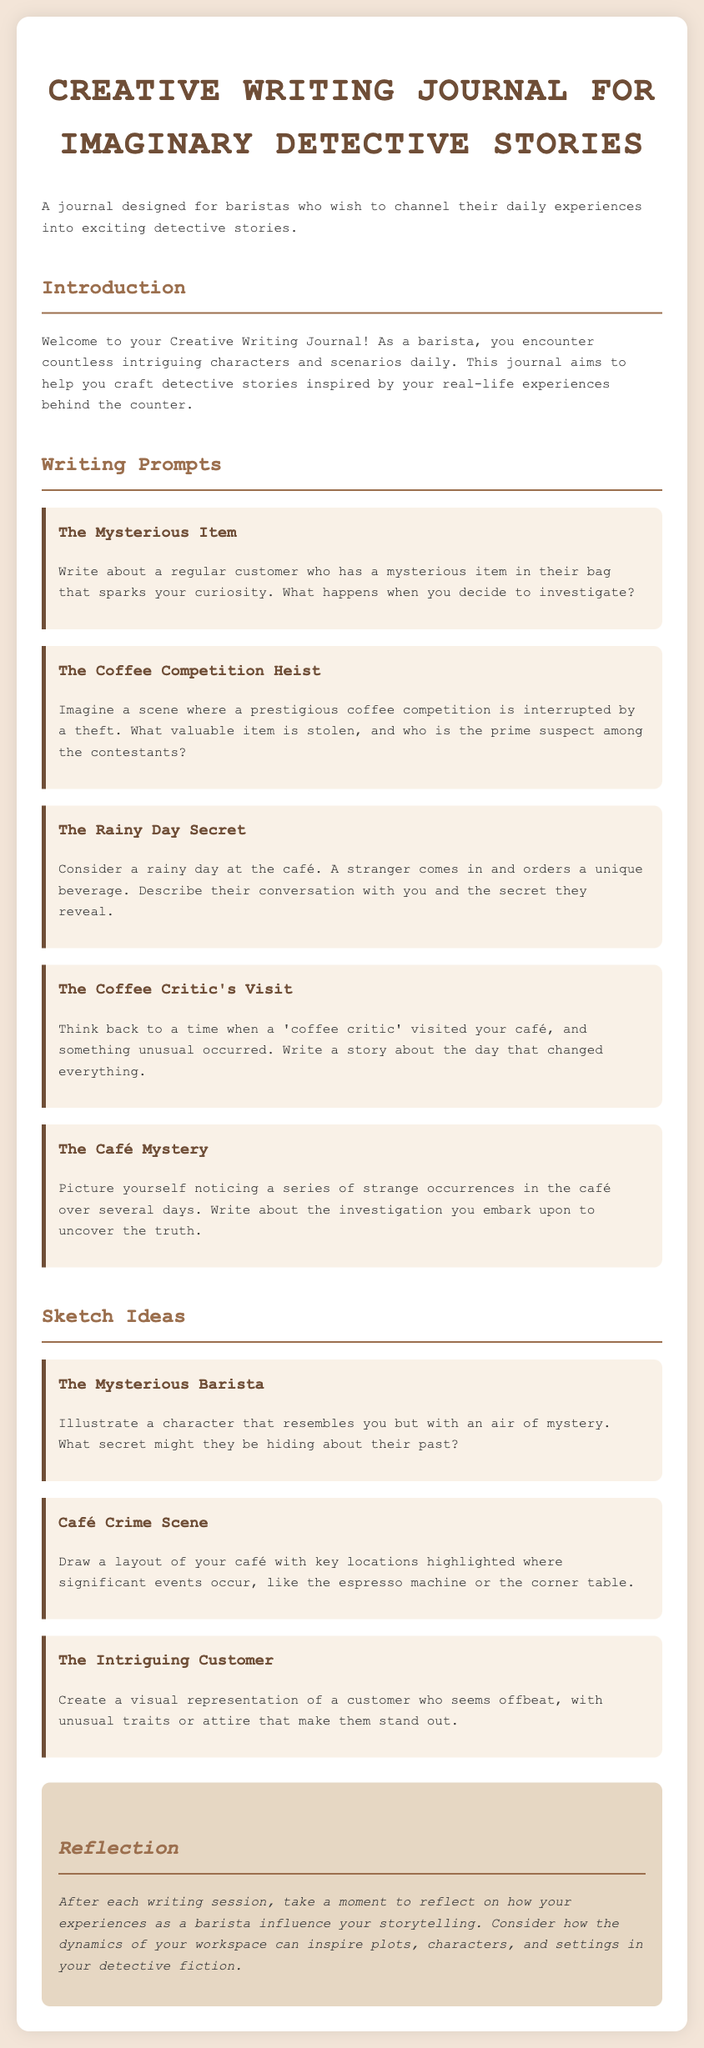what is the title of the document? The title is prominently displayed at the top of the document and provides insight into its content.
Answer: Creative Writing Journal for Imaginary Detective Stories what is the main purpose of the journal? The introduction outlines the main objective of the journal for its users, capturing the spirit of barista experiences.
Answer: To channel daily experiences into exciting detective stories how many writing prompts are provided in the document? The number of writing prompts can be identified by counting the sections dedicated to them.
Answer: Five name one of the writing prompts mentioned. A specific example can be found by reviewing the titles under the writing prompts section.
Answer: The Mysterious Item what is a suggested activity after each writing session? The reflection section describes the activity that encourages self-assessment of the writing process.
Answer: Reflection on experiences how are the sketch ideas presented in the document? The sketches section includes descriptions that guide users in their illustrative creations.
Answer: As characters or scenes to illustrate what is the background color of the document? The background color is specified in the styling section of the document, which affects overall aesthetics.
Answer: #f3e5d8 what type of characters does the journal encourage baristas to create? The introduction and prompts emphasize character creation based on real-life inspirations encountered daily.
Answer: Detective characters 